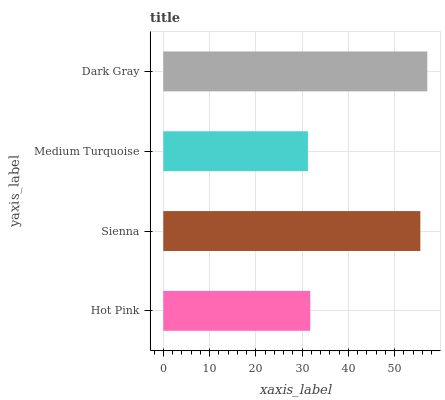Is Medium Turquoise the minimum?
Answer yes or no. Yes. Is Dark Gray the maximum?
Answer yes or no. Yes. Is Sienna the minimum?
Answer yes or no. No. Is Sienna the maximum?
Answer yes or no. No. Is Sienna greater than Hot Pink?
Answer yes or no. Yes. Is Hot Pink less than Sienna?
Answer yes or no. Yes. Is Hot Pink greater than Sienna?
Answer yes or no. No. Is Sienna less than Hot Pink?
Answer yes or no. No. Is Sienna the high median?
Answer yes or no. Yes. Is Hot Pink the low median?
Answer yes or no. Yes. Is Dark Gray the high median?
Answer yes or no. No. Is Medium Turquoise the low median?
Answer yes or no. No. 